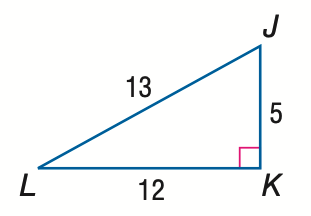Answer the mathemtical geometry problem and directly provide the correct option letter.
Question: Express the ratio of \sin L as a decimal to the nearest hundredth.
Choices: A: 0.38 B: 0.42 C: 0.92 D: 2.40 A 